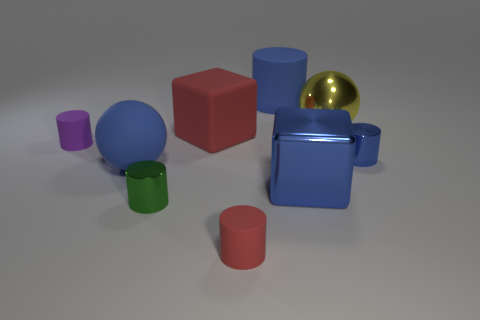Subtract all green cylinders. How many cylinders are left? 4 Subtract all red cylinders. How many cylinders are left? 4 Subtract all brown cylinders. Subtract all blue blocks. How many cylinders are left? 5 Subtract all cylinders. How many objects are left? 4 Add 9 big rubber spheres. How many big rubber spheres exist? 10 Subtract 0 purple balls. How many objects are left? 9 Subtract all yellow things. Subtract all red objects. How many objects are left? 6 Add 9 big blue blocks. How many big blue blocks are left? 10 